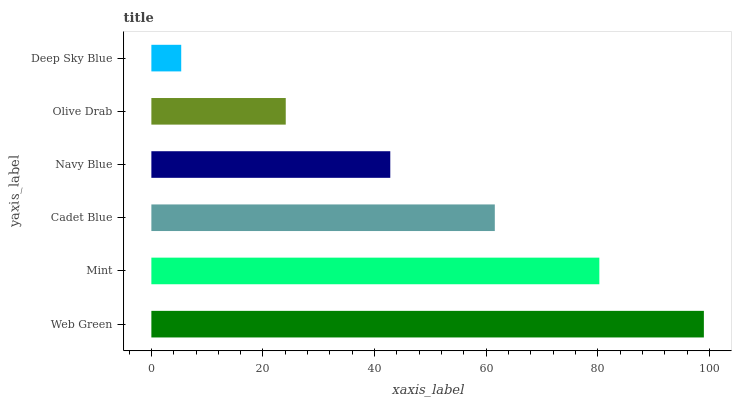Is Deep Sky Blue the minimum?
Answer yes or no. Yes. Is Web Green the maximum?
Answer yes or no. Yes. Is Mint the minimum?
Answer yes or no. No. Is Mint the maximum?
Answer yes or no. No. Is Web Green greater than Mint?
Answer yes or no. Yes. Is Mint less than Web Green?
Answer yes or no. Yes. Is Mint greater than Web Green?
Answer yes or no. No. Is Web Green less than Mint?
Answer yes or no. No. Is Cadet Blue the high median?
Answer yes or no. Yes. Is Navy Blue the low median?
Answer yes or no. Yes. Is Mint the high median?
Answer yes or no. No. Is Olive Drab the low median?
Answer yes or no. No. 